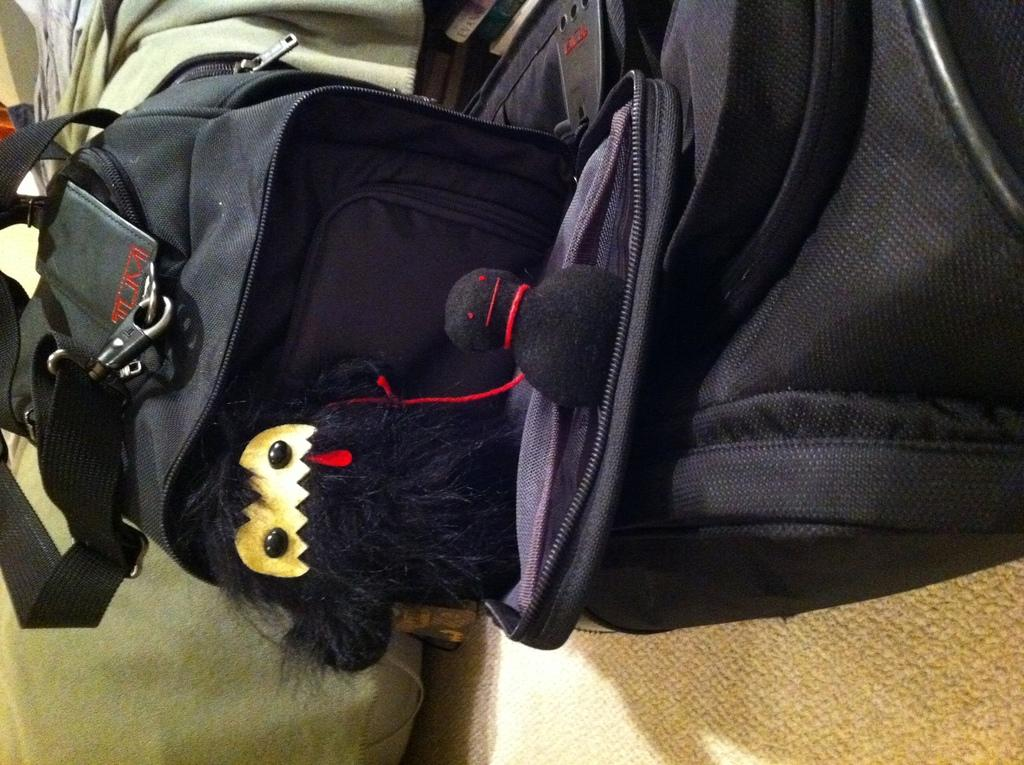What object can be seen in the image? A: There is a toy in the image. Where is the toy located? The toy is in a bag. What is the color of the bag? The bag is black in color. How many spiders are crawling on the toy in the image? There are no spiders present in the image; it only features a toy in a black bag. 